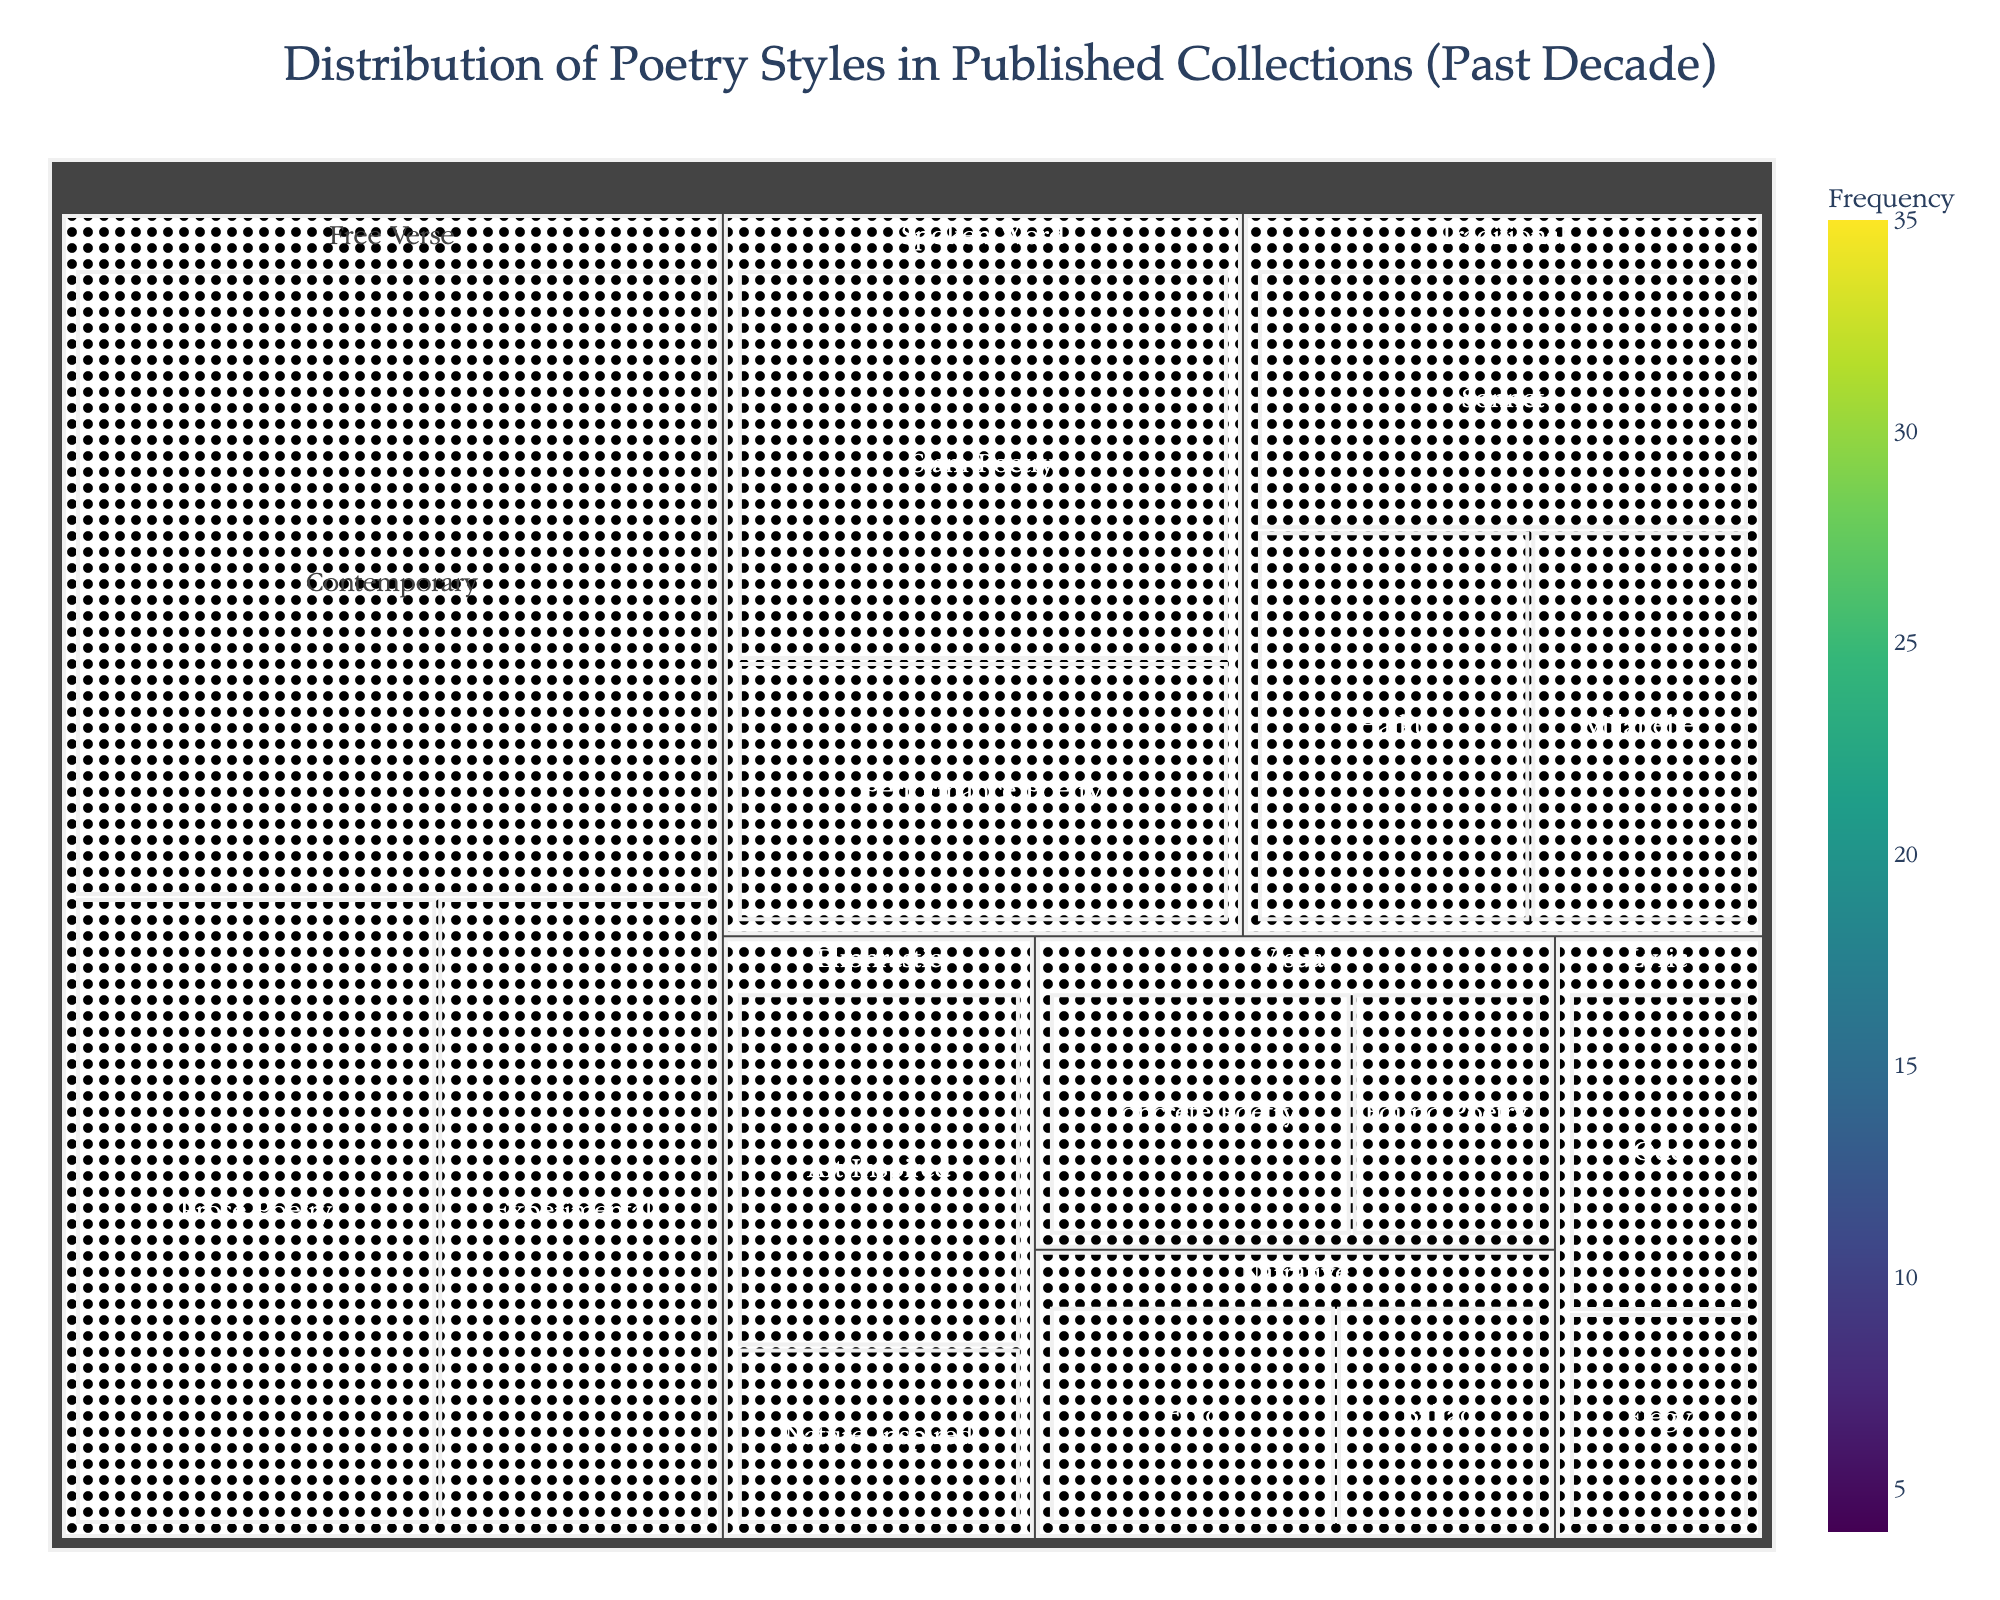What's the most frequent poetry style in published collections over the past decade? The treemap visually represents the sizes of each poetry style segment, with larger areas indicating higher frequencies. The "Free Verse" category occupies the largest segment, specifically, "Contemporary" under "Free Verse" has the largest value.
Answer: Free Verse (Contemporary) Which two subcategories under 'Traditional' together make up the majority of its publications? You can observe the sizes of the rectangles under the "Traditional" category. The two largest subcategories are "Sonnet" (12) and "Haiku" (10), and their combined value is greater than the remaining subcategory ("Villanelle", 8).
Answer: Sonnet and Haiku What is the combined value for all subcategories under 'Spoken Word'? The "Spoken Word" category consists of "Slam Poetry" (18) and "Performance Poetry" (12). Adding these values gives 18 + 12 = 30.
Answer: 30 Which subcategory has a higher frequency: 'Art-Inspired' under 'Ekphrastic' or 'Lyric' as a whole category? "Art-Inspired" under "Ekphrastic" has a value of 10. The total value for the "Lyric" category is the sum of "Ode" (6) and "Elegy" (4), which is 6 + 4 = 10. Both have the same frequency.
Answer: Both are equal How does the frequency of 'Concrete Poetry' compare to 'Villanelle'? "Concrete Poetry" under the "Visual" category has a value of 8, the same as "Villanelle" under "Traditional", both having an equal frequency in the treemap.
Answer: Equal What is the least frequent subcategory in the 'Narrative' category? The "Narrative" category has two subcategories: "Epic" (7) and "Ballad" (5). "Ballad" has the smaller value and is therefore the least frequent.
Answer: Ballad What is the cumulative value of all subcategories under 'Free Verse'? The subcategories under "Free Verse" are "Contemporary" (35), "Prose Poetry" (20), and "Experimental" (15). Adding these values: 35 + 20 + 15 = 70.
Answer: 70 Is 'Slam Poetry' more frequent than 'Sonnet'? In the treemap, "Slam Poetry" under "Spoken Word" has a value of 18, whereas "Sonnet" under "Traditional" has a value of 12. Therefore, "Slam Poetry" is more frequent.
Answer: Yes Which category has more subcategories: 'Visual' or 'Ekphrastic'? "Visual" has two subcategories: "Concrete Poetry" and "Found Poetry". "Ekphrastic" also has two subcategories: "Art-Inspired" and "Nature-Inspired". Thus, both categories have an equal number of subcategories.
Answer: Equal What is the percentage of 'Haiku' in the 'Traditional' category? "Haiku" has a value of 10. The total for "Traditional" is the sum of its subcategories: "Sonnet" (12) + "Haiku" (10) + "Villanelle" (8) = 30. The percentage is (10 / 30) * 100 = 33.33%.
Answer: 33.33% 